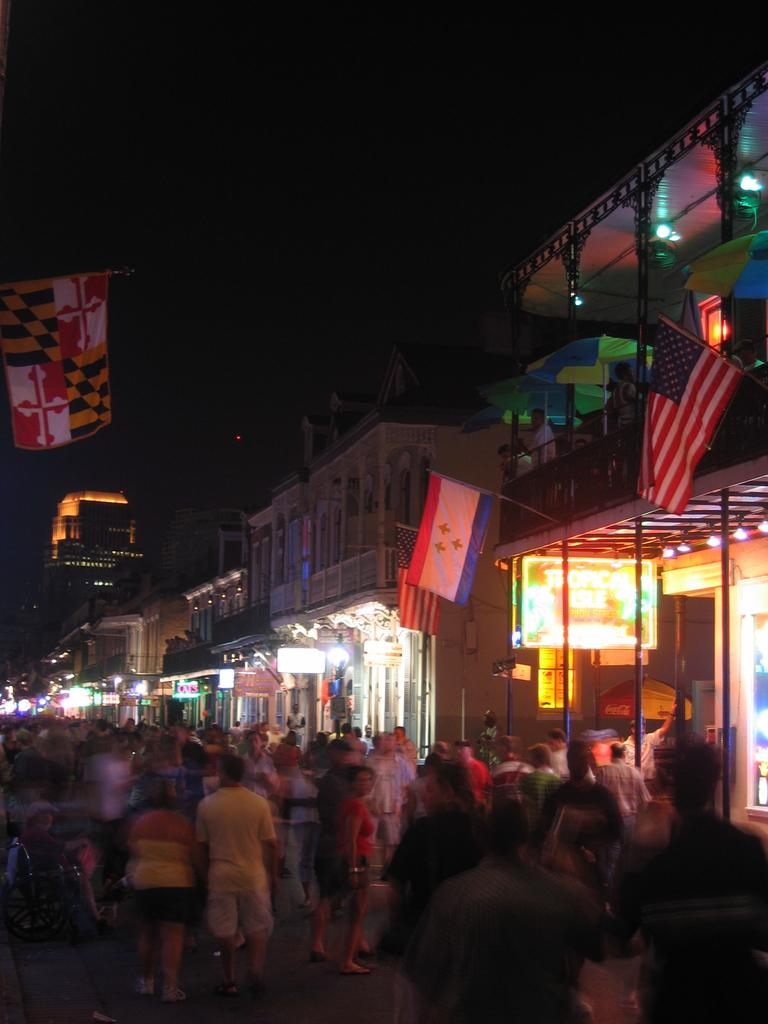What are the people in the image doing? The people in the image are standing on the road. What can be seen on the flag posts? There are flags on the flag posts. What type of structures are visible in the image? There are buildings in the image. What type of lighting is present in the image? There are electric lights in the image. What part of the natural environment is visible in the image? The sky is visible in the image. What type of whip can be seen in the hands of the people in the image? There is no whip present in the image; the people are simply standing on the road. 